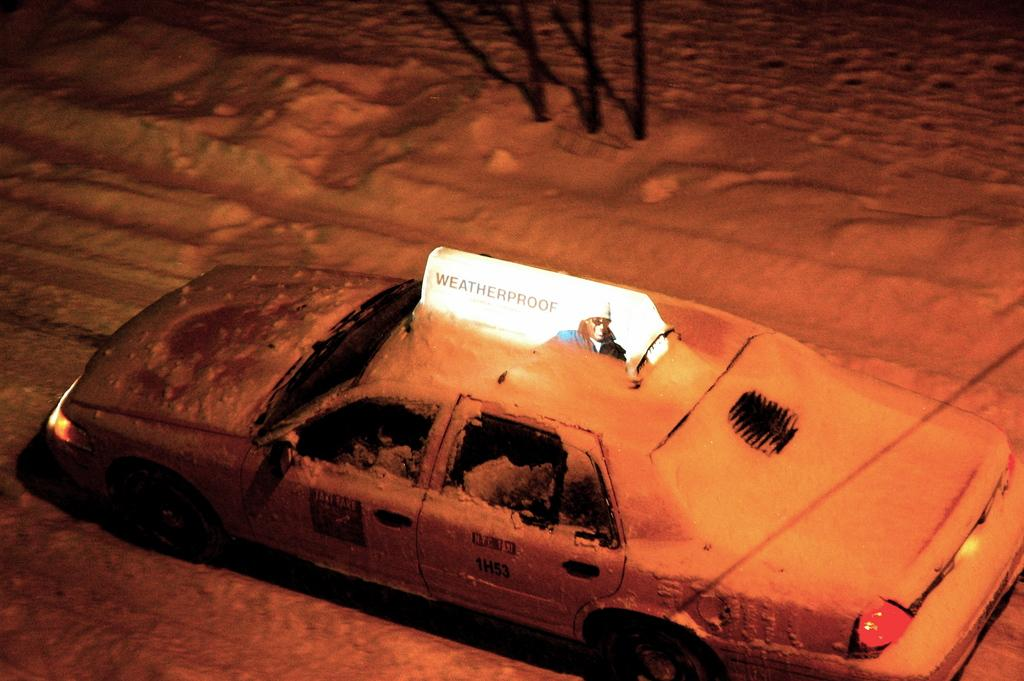<image>
Render a clear and concise summary of the photo. a cab that has the name weatherproof at the top of it 